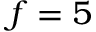<formula> <loc_0><loc_0><loc_500><loc_500>f = 5</formula> 